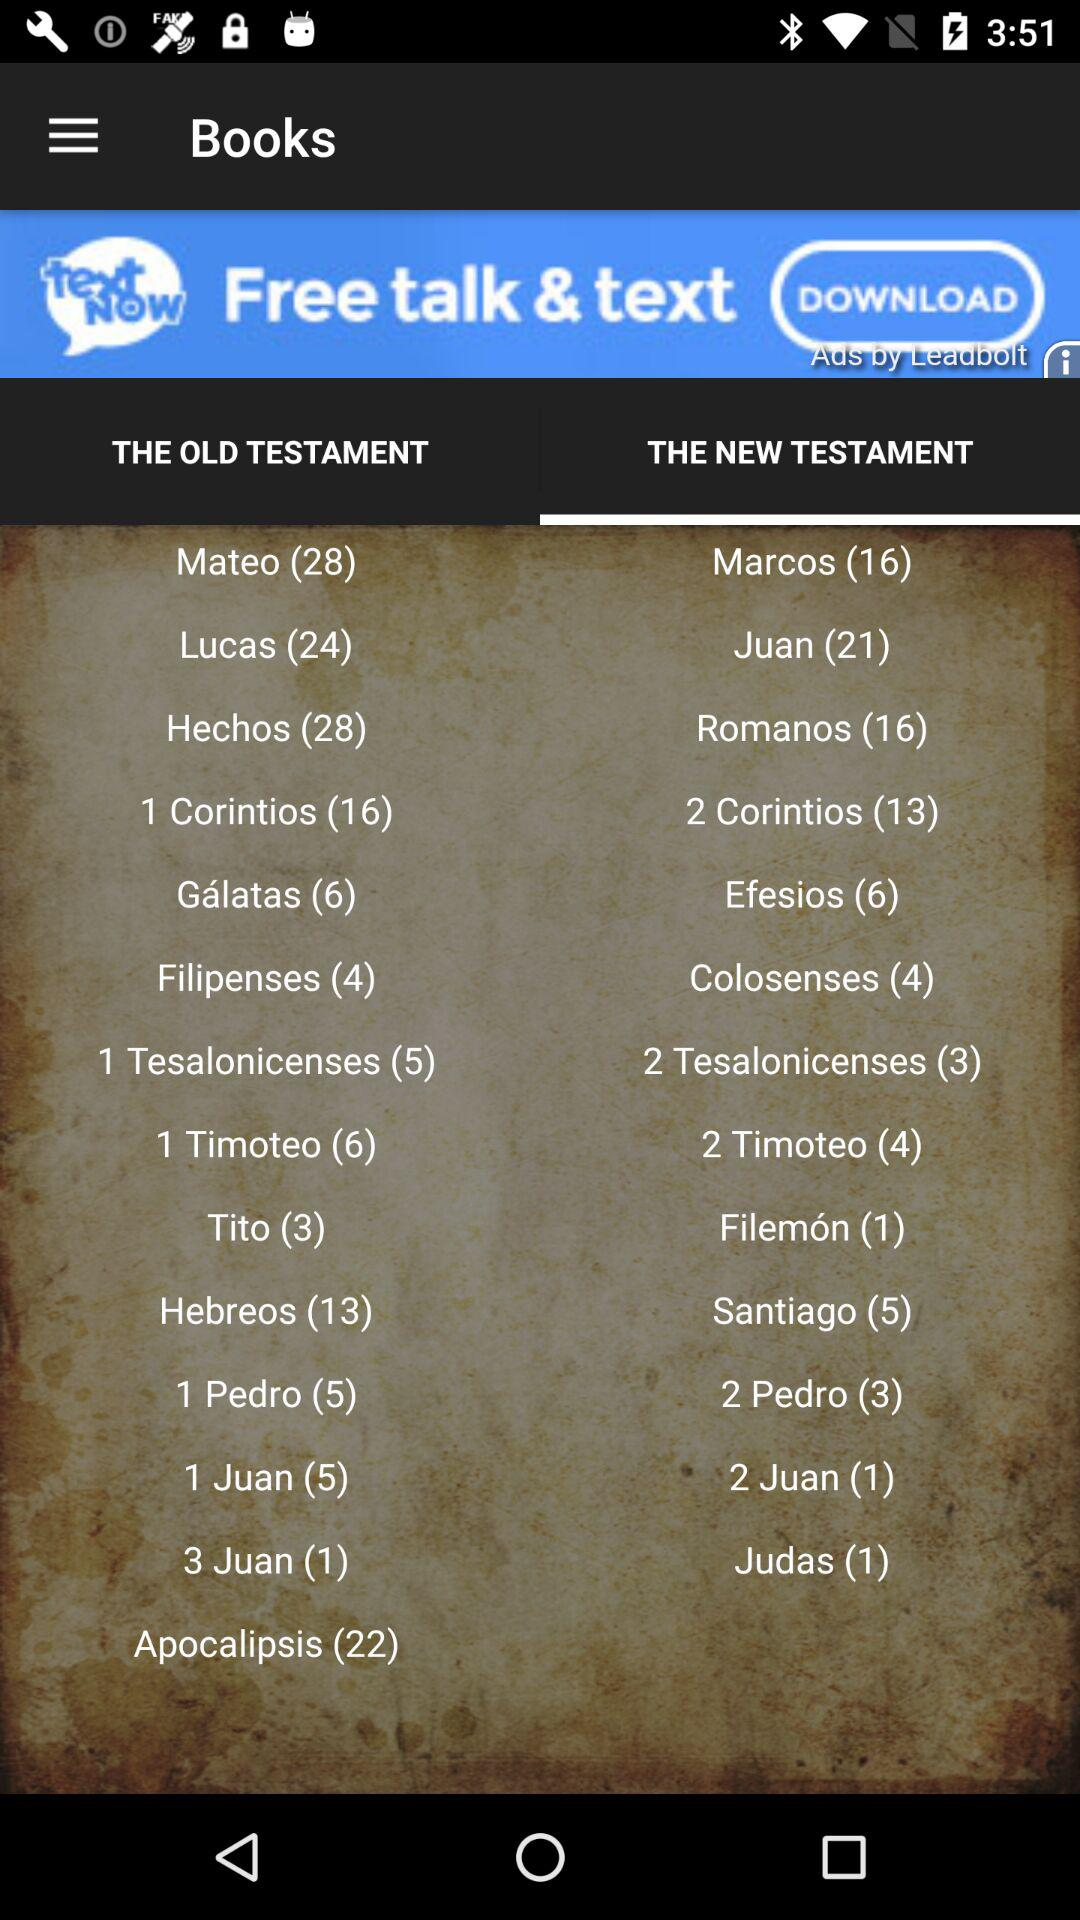How many books are there in the "Marcos" There are 16 books in the "Marcos". 